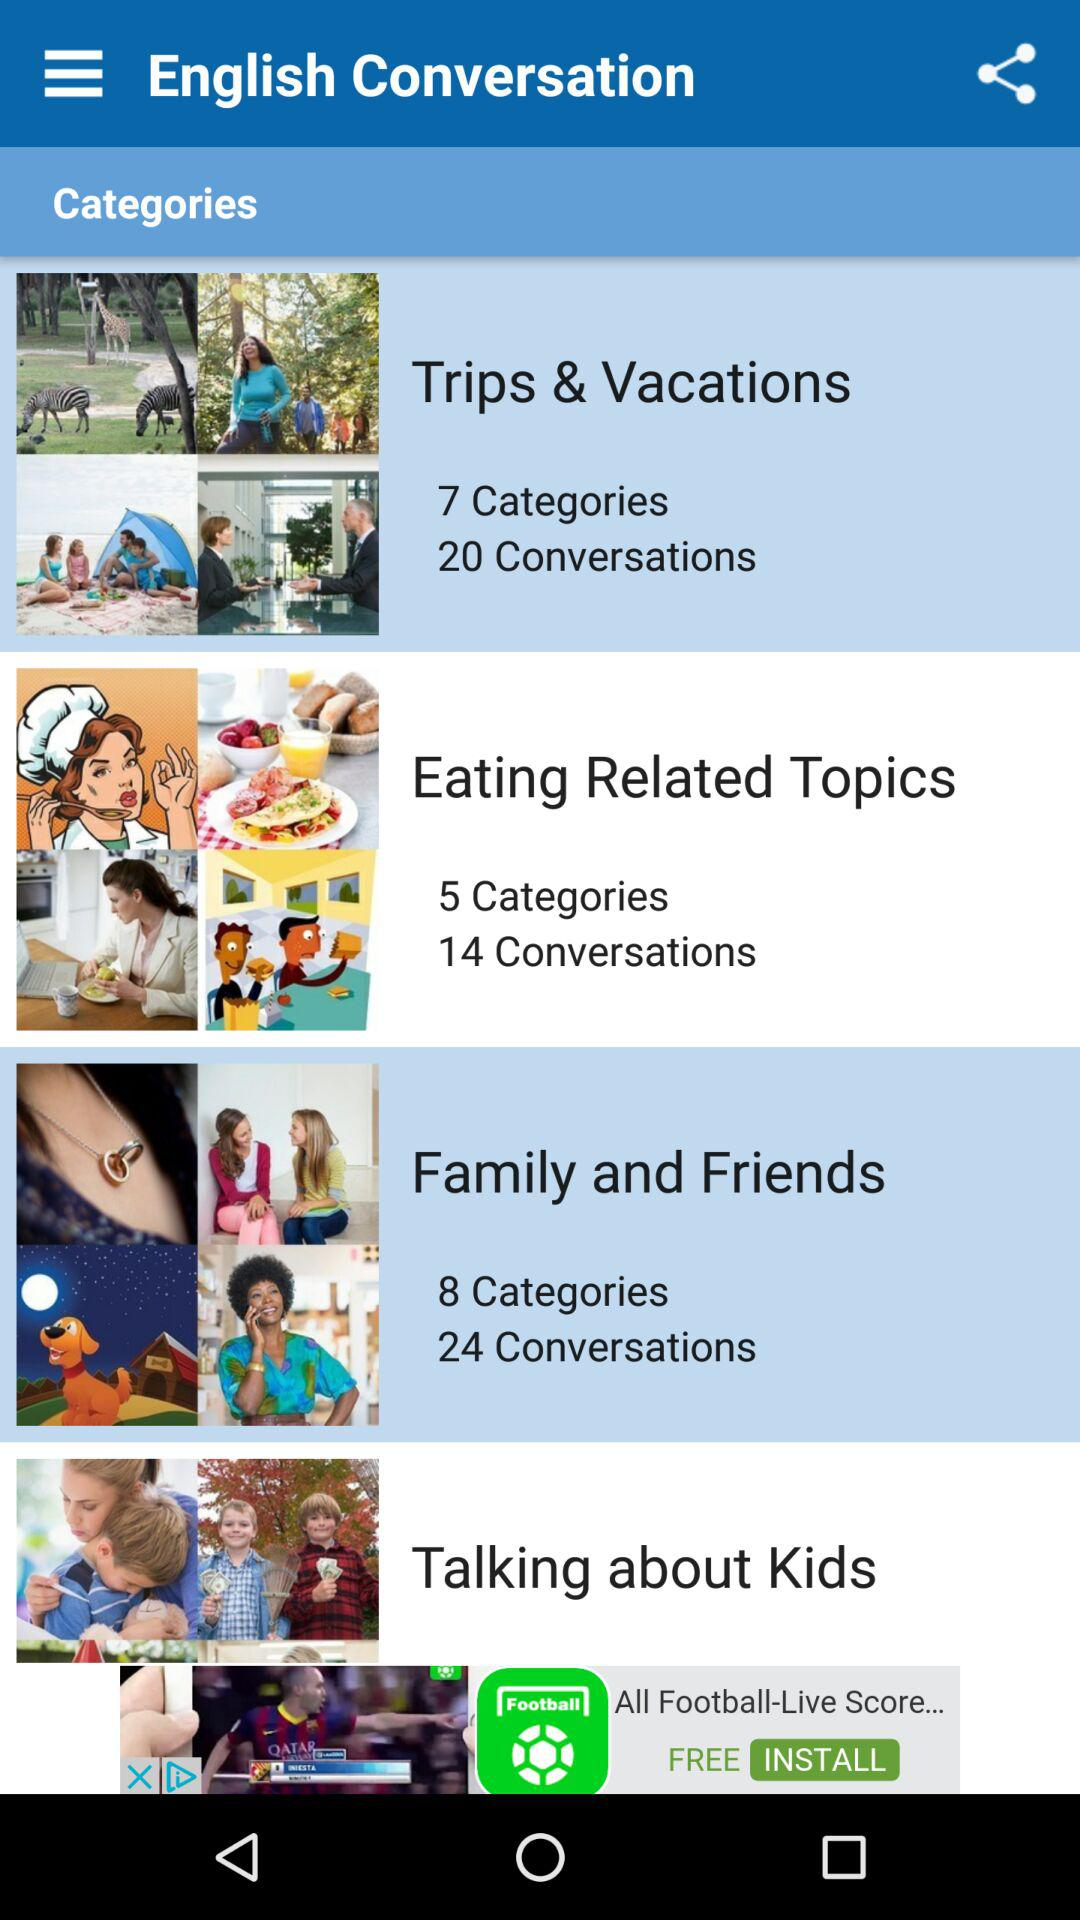What is the number of the categories and conversations in family and friends? The number of the categories is 8 and the number of conversations is 24 in family and friends. 